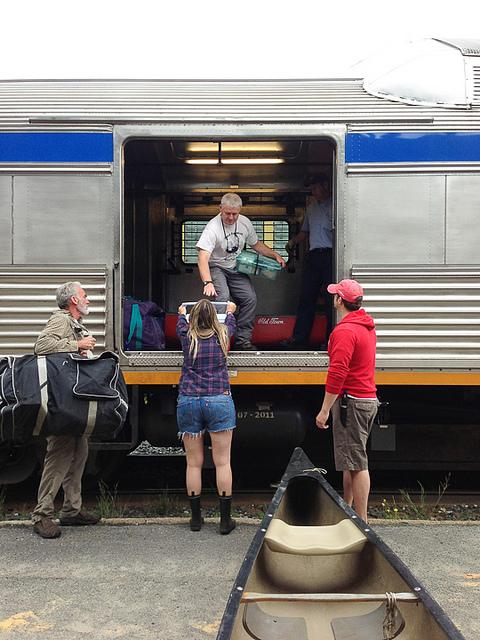What is this type of train car called? Please explain your reasoning. cargo. The people are putting their luggage in this train car. the passengers ride and sleep in other cars. 